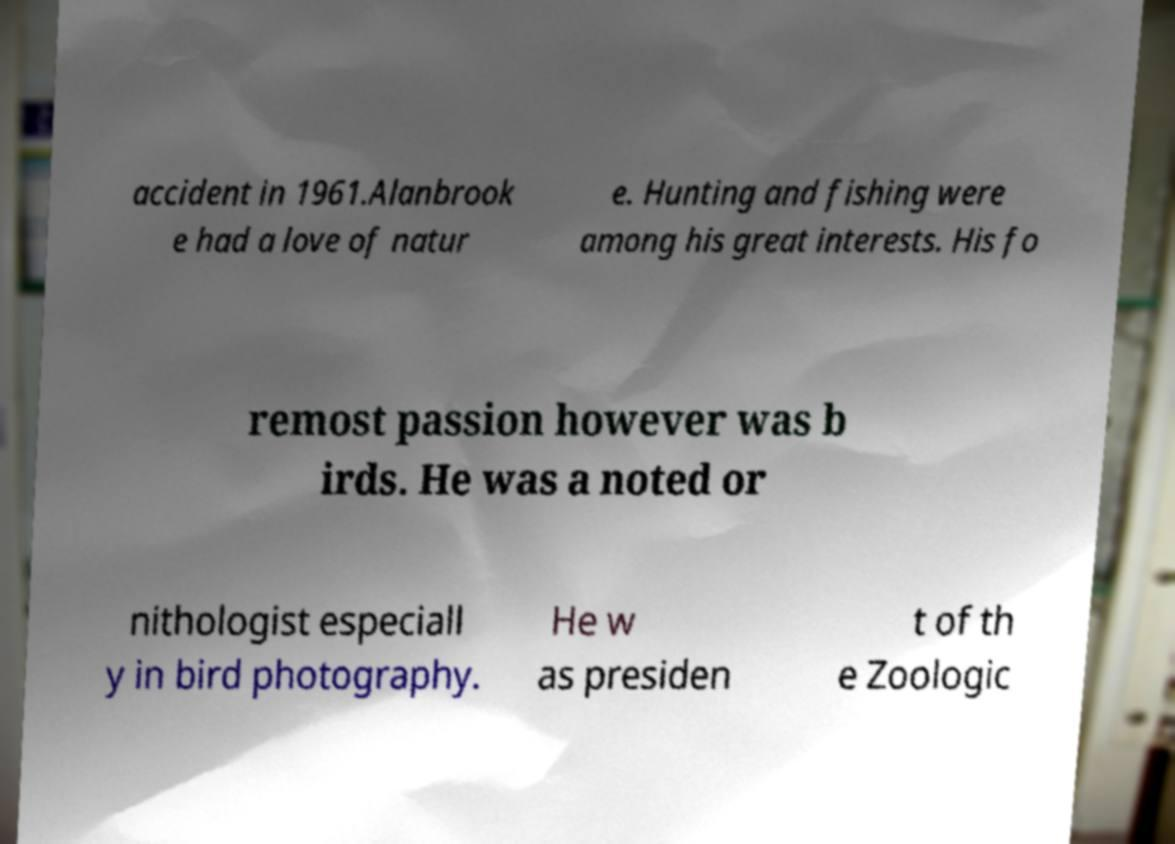Can you read and provide the text displayed in the image?This photo seems to have some interesting text. Can you extract and type it out for me? accident in 1961.Alanbrook e had a love of natur e. Hunting and fishing were among his great interests. His fo remost passion however was b irds. He was a noted or nithologist especiall y in bird photography. He w as presiden t of th e Zoologic 